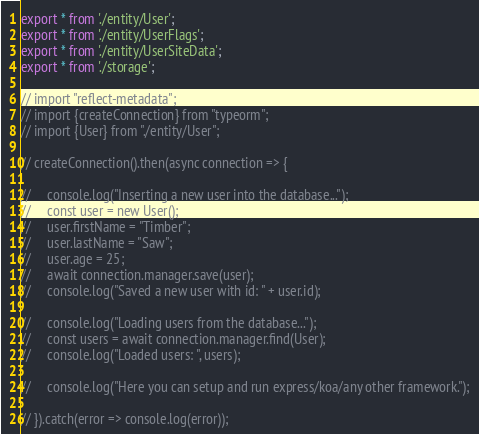<code> <loc_0><loc_0><loc_500><loc_500><_TypeScript_>export * from './entity/User';
export * from './entity/UserFlags';
export * from './entity/UserSiteData';
export * from './storage';

// import "reflect-metadata";
// import {createConnection} from "typeorm";
// import {User} from "./entity/User";

// createConnection().then(async connection => {

//     console.log("Inserting a new user into the database...");
//     const user = new User();
//     user.firstName = "Timber";
//     user.lastName = "Saw";
//     user.age = 25;
//     await connection.manager.save(user);
//     console.log("Saved a new user with id: " + user.id);

//     console.log("Loading users from the database...");
//     const users = await connection.manager.find(User);
//     console.log("Loaded users: ", users);

//     console.log("Here you can setup and run express/koa/any other framework.");

// }).catch(error => console.log(error));
</code> 